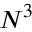<formula> <loc_0><loc_0><loc_500><loc_500>N ^ { 3 }</formula> 